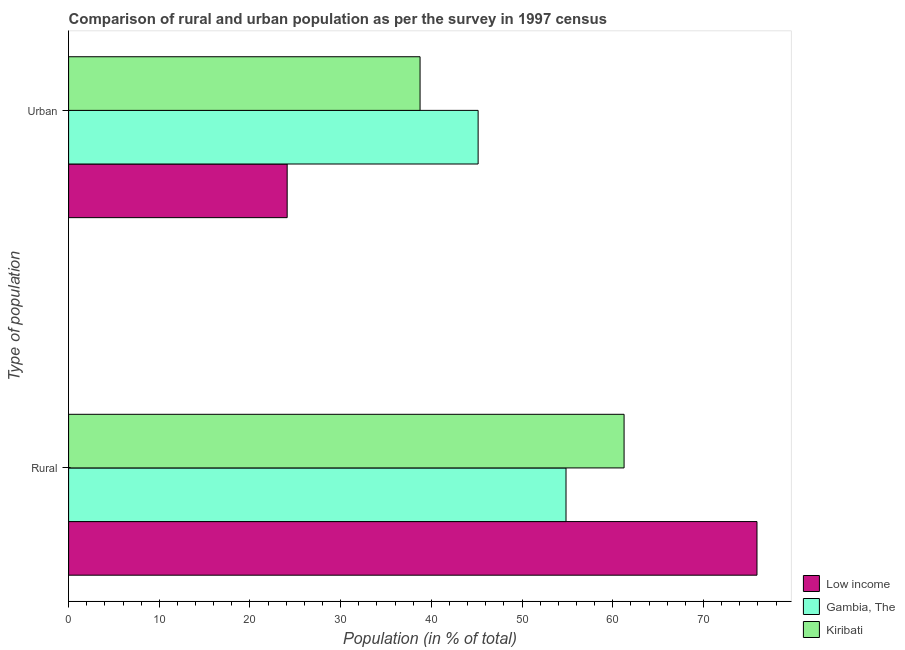Are the number of bars per tick equal to the number of legend labels?
Offer a terse response. Yes. Are the number of bars on each tick of the Y-axis equal?
Your answer should be compact. Yes. What is the label of the 1st group of bars from the top?
Provide a succinct answer. Urban. What is the rural population in Kiribati?
Make the answer very short. 61.25. Across all countries, what is the maximum rural population?
Your answer should be compact. 75.9. Across all countries, what is the minimum rural population?
Ensure brevity in your answer.  54.84. In which country was the urban population maximum?
Provide a succinct answer. Gambia, The. What is the total urban population in the graph?
Ensure brevity in your answer.  108.01. What is the difference between the urban population in Kiribati and that in Gambia, The?
Ensure brevity in your answer.  -6.4. What is the difference between the urban population in Gambia, The and the rural population in Kiribati?
Provide a succinct answer. -16.09. What is the average rural population per country?
Make the answer very short. 64. What is the difference between the rural population and urban population in Gambia, The?
Your response must be concise. 9.69. In how many countries, is the rural population greater than 64 %?
Provide a succinct answer. 1. What is the ratio of the rural population in Gambia, The to that in Low income?
Ensure brevity in your answer.  0.72. Is the rural population in Kiribati less than that in Gambia, The?
Provide a short and direct response. No. What does the 2nd bar from the top in Rural represents?
Give a very brief answer. Gambia, The. Are all the bars in the graph horizontal?
Provide a succinct answer. Yes. How many countries are there in the graph?
Offer a very short reply. 3. What is the difference between two consecutive major ticks on the X-axis?
Keep it short and to the point. 10. Are the values on the major ticks of X-axis written in scientific E-notation?
Your answer should be very brief. No. Does the graph contain any zero values?
Your answer should be very brief. No. Where does the legend appear in the graph?
Your answer should be very brief. Bottom right. How are the legend labels stacked?
Provide a succinct answer. Vertical. What is the title of the graph?
Ensure brevity in your answer.  Comparison of rural and urban population as per the survey in 1997 census. Does "East Asia (developing only)" appear as one of the legend labels in the graph?
Offer a very short reply. No. What is the label or title of the X-axis?
Your answer should be very brief. Population (in % of total). What is the label or title of the Y-axis?
Your answer should be very brief. Type of population. What is the Population (in % of total) in Low income in Rural?
Offer a very short reply. 75.9. What is the Population (in % of total) of Gambia, The in Rural?
Make the answer very short. 54.84. What is the Population (in % of total) of Kiribati in Rural?
Ensure brevity in your answer.  61.25. What is the Population (in % of total) in Low income in Urban?
Provide a short and direct response. 24.1. What is the Population (in % of total) of Gambia, The in Urban?
Provide a succinct answer. 45.16. What is the Population (in % of total) in Kiribati in Urban?
Your response must be concise. 38.75. Across all Type of population, what is the maximum Population (in % of total) of Low income?
Provide a short and direct response. 75.9. Across all Type of population, what is the maximum Population (in % of total) of Gambia, The?
Provide a short and direct response. 54.84. Across all Type of population, what is the maximum Population (in % of total) of Kiribati?
Give a very brief answer. 61.25. Across all Type of population, what is the minimum Population (in % of total) of Low income?
Provide a succinct answer. 24.1. Across all Type of population, what is the minimum Population (in % of total) of Gambia, The?
Your answer should be very brief. 45.16. Across all Type of population, what is the minimum Population (in % of total) in Kiribati?
Offer a very short reply. 38.75. What is the total Population (in % of total) of Low income in the graph?
Your answer should be compact. 100. What is the total Population (in % of total) of Gambia, The in the graph?
Your response must be concise. 100. What is the difference between the Population (in % of total) in Low income in Rural and that in Urban?
Give a very brief answer. 51.8. What is the difference between the Population (in % of total) of Gambia, The in Rural and that in Urban?
Your answer should be very brief. 9.69. What is the difference between the Population (in % of total) of Kiribati in Rural and that in Urban?
Provide a succinct answer. 22.5. What is the difference between the Population (in % of total) of Low income in Rural and the Population (in % of total) of Gambia, The in Urban?
Keep it short and to the point. 30.75. What is the difference between the Population (in % of total) in Low income in Rural and the Population (in % of total) in Kiribati in Urban?
Your answer should be very brief. 37.15. What is the difference between the Population (in % of total) in Gambia, The in Rural and the Population (in % of total) in Kiribati in Urban?
Keep it short and to the point. 16.09. What is the average Population (in % of total) in Low income per Type of population?
Offer a terse response. 50. What is the average Population (in % of total) in Gambia, The per Type of population?
Offer a very short reply. 50. What is the difference between the Population (in % of total) of Low income and Population (in % of total) of Gambia, The in Rural?
Ensure brevity in your answer.  21.06. What is the difference between the Population (in % of total) of Low income and Population (in % of total) of Kiribati in Rural?
Ensure brevity in your answer.  14.65. What is the difference between the Population (in % of total) in Gambia, The and Population (in % of total) in Kiribati in Rural?
Give a very brief answer. -6.4. What is the difference between the Population (in % of total) in Low income and Population (in % of total) in Gambia, The in Urban?
Your answer should be very brief. -21.06. What is the difference between the Population (in % of total) of Low income and Population (in % of total) of Kiribati in Urban?
Give a very brief answer. -14.65. What is the difference between the Population (in % of total) of Gambia, The and Population (in % of total) of Kiribati in Urban?
Provide a succinct answer. 6.4. What is the ratio of the Population (in % of total) in Low income in Rural to that in Urban?
Give a very brief answer. 3.15. What is the ratio of the Population (in % of total) of Gambia, The in Rural to that in Urban?
Offer a very short reply. 1.21. What is the ratio of the Population (in % of total) of Kiribati in Rural to that in Urban?
Provide a short and direct response. 1.58. What is the difference between the highest and the second highest Population (in % of total) in Low income?
Keep it short and to the point. 51.8. What is the difference between the highest and the second highest Population (in % of total) of Gambia, The?
Your response must be concise. 9.69. What is the difference between the highest and the second highest Population (in % of total) of Kiribati?
Provide a succinct answer. 22.5. What is the difference between the highest and the lowest Population (in % of total) of Low income?
Provide a succinct answer. 51.8. What is the difference between the highest and the lowest Population (in % of total) in Gambia, The?
Offer a terse response. 9.69. What is the difference between the highest and the lowest Population (in % of total) in Kiribati?
Make the answer very short. 22.5. 